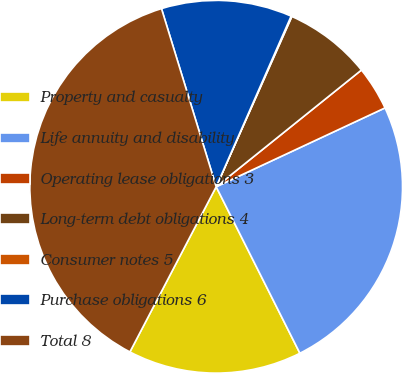Convert chart. <chart><loc_0><loc_0><loc_500><loc_500><pie_chart><fcel>Property and casualty<fcel>Life annuity and disability<fcel>Operating lease obligations 3<fcel>Long-term debt obligations 4<fcel>Consumer notes 5<fcel>Purchase obligations 6<fcel>Total 8<nl><fcel>15.08%<fcel>24.54%<fcel>3.82%<fcel>7.57%<fcel>0.07%<fcel>11.33%<fcel>37.6%<nl></chart> 